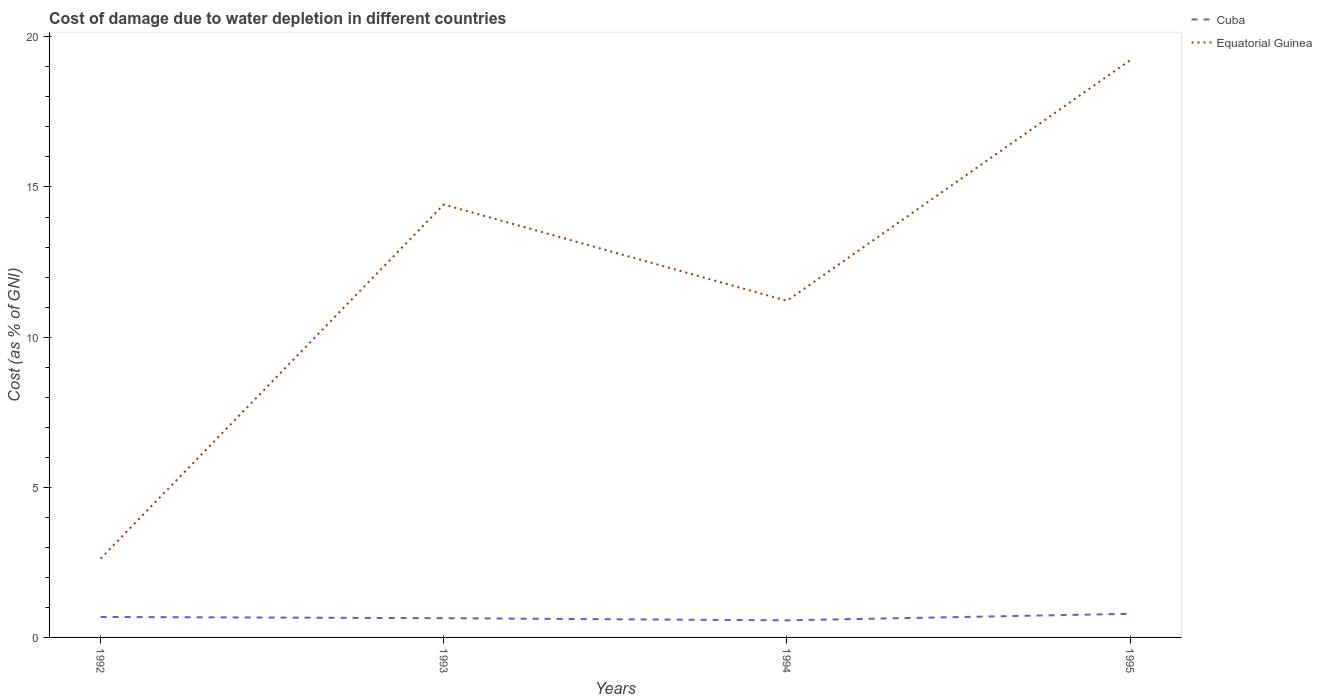Across all years, what is the maximum cost of damage caused due to water depletion in Cuba?
Make the answer very short. 0.57. In which year was the cost of damage caused due to water depletion in Cuba maximum?
Keep it short and to the point. 1994. What is the total cost of damage caused due to water depletion in Cuba in the graph?
Your response must be concise. -0.22. What is the difference between the highest and the second highest cost of damage caused due to water depletion in Cuba?
Make the answer very short. 0.22. What is the difference between the highest and the lowest cost of damage caused due to water depletion in Cuba?
Your response must be concise. 2. Is the cost of damage caused due to water depletion in Equatorial Guinea strictly greater than the cost of damage caused due to water depletion in Cuba over the years?
Give a very brief answer. No. Are the values on the major ticks of Y-axis written in scientific E-notation?
Keep it short and to the point. No. Does the graph contain any zero values?
Give a very brief answer. No. Does the graph contain grids?
Offer a very short reply. No. What is the title of the graph?
Offer a terse response. Cost of damage due to water depletion in different countries. What is the label or title of the Y-axis?
Provide a succinct answer. Cost (as % of GNI). What is the Cost (as % of GNI) in Cuba in 1992?
Provide a succinct answer. 0.68. What is the Cost (as % of GNI) of Equatorial Guinea in 1992?
Keep it short and to the point. 2.63. What is the Cost (as % of GNI) of Cuba in 1993?
Give a very brief answer. 0.64. What is the Cost (as % of GNI) in Equatorial Guinea in 1993?
Your answer should be compact. 14.42. What is the Cost (as % of GNI) in Cuba in 1994?
Ensure brevity in your answer.  0.57. What is the Cost (as % of GNI) of Equatorial Guinea in 1994?
Your answer should be compact. 11.21. What is the Cost (as % of GNI) in Cuba in 1995?
Provide a succinct answer. 0.79. What is the Cost (as % of GNI) in Equatorial Guinea in 1995?
Make the answer very short. 19.22. Across all years, what is the maximum Cost (as % of GNI) in Cuba?
Offer a terse response. 0.79. Across all years, what is the maximum Cost (as % of GNI) in Equatorial Guinea?
Provide a short and direct response. 19.22. Across all years, what is the minimum Cost (as % of GNI) of Cuba?
Give a very brief answer. 0.57. Across all years, what is the minimum Cost (as % of GNI) in Equatorial Guinea?
Your response must be concise. 2.63. What is the total Cost (as % of GNI) in Cuba in the graph?
Provide a short and direct response. 2.68. What is the total Cost (as % of GNI) in Equatorial Guinea in the graph?
Offer a very short reply. 47.47. What is the difference between the Cost (as % of GNI) in Cuba in 1992 and that in 1993?
Your answer should be very brief. 0.04. What is the difference between the Cost (as % of GNI) of Equatorial Guinea in 1992 and that in 1993?
Provide a short and direct response. -11.79. What is the difference between the Cost (as % of GNI) of Cuba in 1992 and that in 1994?
Provide a short and direct response. 0.11. What is the difference between the Cost (as % of GNI) in Equatorial Guinea in 1992 and that in 1994?
Offer a terse response. -8.58. What is the difference between the Cost (as % of GNI) in Cuba in 1992 and that in 1995?
Give a very brief answer. -0.11. What is the difference between the Cost (as % of GNI) in Equatorial Guinea in 1992 and that in 1995?
Your answer should be compact. -16.59. What is the difference between the Cost (as % of GNI) in Cuba in 1993 and that in 1994?
Make the answer very short. 0.07. What is the difference between the Cost (as % of GNI) of Equatorial Guinea in 1993 and that in 1994?
Keep it short and to the point. 3.21. What is the difference between the Cost (as % of GNI) of Cuba in 1993 and that in 1995?
Give a very brief answer. -0.15. What is the difference between the Cost (as % of GNI) in Equatorial Guinea in 1993 and that in 1995?
Keep it short and to the point. -4.8. What is the difference between the Cost (as % of GNI) of Cuba in 1994 and that in 1995?
Make the answer very short. -0.22. What is the difference between the Cost (as % of GNI) in Equatorial Guinea in 1994 and that in 1995?
Your answer should be compact. -8.01. What is the difference between the Cost (as % of GNI) of Cuba in 1992 and the Cost (as % of GNI) of Equatorial Guinea in 1993?
Offer a terse response. -13.73. What is the difference between the Cost (as % of GNI) of Cuba in 1992 and the Cost (as % of GNI) of Equatorial Guinea in 1994?
Keep it short and to the point. -10.53. What is the difference between the Cost (as % of GNI) in Cuba in 1992 and the Cost (as % of GNI) in Equatorial Guinea in 1995?
Ensure brevity in your answer.  -18.54. What is the difference between the Cost (as % of GNI) in Cuba in 1993 and the Cost (as % of GNI) in Equatorial Guinea in 1994?
Offer a terse response. -10.57. What is the difference between the Cost (as % of GNI) in Cuba in 1993 and the Cost (as % of GNI) in Equatorial Guinea in 1995?
Make the answer very short. -18.58. What is the difference between the Cost (as % of GNI) in Cuba in 1994 and the Cost (as % of GNI) in Equatorial Guinea in 1995?
Give a very brief answer. -18.65. What is the average Cost (as % of GNI) in Cuba per year?
Offer a very short reply. 0.67. What is the average Cost (as % of GNI) in Equatorial Guinea per year?
Make the answer very short. 11.87. In the year 1992, what is the difference between the Cost (as % of GNI) of Cuba and Cost (as % of GNI) of Equatorial Guinea?
Offer a terse response. -1.94. In the year 1993, what is the difference between the Cost (as % of GNI) in Cuba and Cost (as % of GNI) in Equatorial Guinea?
Provide a short and direct response. -13.78. In the year 1994, what is the difference between the Cost (as % of GNI) in Cuba and Cost (as % of GNI) in Equatorial Guinea?
Keep it short and to the point. -10.64. In the year 1995, what is the difference between the Cost (as % of GNI) in Cuba and Cost (as % of GNI) in Equatorial Guinea?
Provide a succinct answer. -18.43. What is the ratio of the Cost (as % of GNI) in Cuba in 1992 to that in 1993?
Your answer should be compact. 1.06. What is the ratio of the Cost (as % of GNI) in Equatorial Guinea in 1992 to that in 1993?
Keep it short and to the point. 0.18. What is the ratio of the Cost (as % of GNI) in Cuba in 1992 to that in 1994?
Provide a short and direct response. 1.2. What is the ratio of the Cost (as % of GNI) of Equatorial Guinea in 1992 to that in 1994?
Provide a succinct answer. 0.23. What is the ratio of the Cost (as % of GNI) in Cuba in 1992 to that in 1995?
Offer a terse response. 0.87. What is the ratio of the Cost (as % of GNI) of Equatorial Guinea in 1992 to that in 1995?
Offer a very short reply. 0.14. What is the ratio of the Cost (as % of GNI) of Cuba in 1993 to that in 1994?
Provide a short and direct response. 1.13. What is the ratio of the Cost (as % of GNI) of Equatorial Guinea in 1993 to that in 1994?
Give a very brief answer. 1.29. What is the ratio of the Cost (as % of GNI) in Cuba in 1993 to that in 1995?
Keep it short and to the point. 0.81. What is the ratio of the Cost (as % of GNI) of Equatorial Guinea in 1993 to that in 1995?
Give a very brief answer. 0.75. What is the ratio of the Cost (as % of GNI) of Cuba in 1994 to that in 1995?
Ensure brevity in your answer.  0.72. What is the ratio of the Cost (as % of GNI) of Equatorial Guinea in 1994 to that in 1995?
Make the answer very short. 0.58. What is the difference between the highest and the second highest Cost (as % of GNI) of Cuba?
Your answer should be very brief. 0.11. What is the difference between the highest and the second highest Cost (as % of GNI) of Equatorial Guinea?
Offer a very short reply. 4.8. What is the difference between the highest and the lowest Cost (as % of GNI) in Cuba?
Provide a succinct answer. 0.22. What is the difference between the highest and the lowest Cost (as % of GNI) of Equatorial Guinea?
Your answer should be compact. 16.59. 